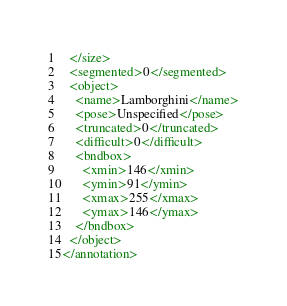Convert code to text. <code><loc_0><loc_0><loc_500><loc_500><_XML_>  </size>
  <segmented>0</segmented>
  <object>
    <name>Lamborghini</name>
    <pose>Unspecified</pose>
    <truncated>0</truncated>
    <difficult>0</difficult>
    <bndbox>
      <xmin>146</xmin>
      <ymin>91</ymin>
      <xmax>255</xmax>
      <ymax>146</ymax>
    </bndbox>
  </object>
</annotation>
</code> 